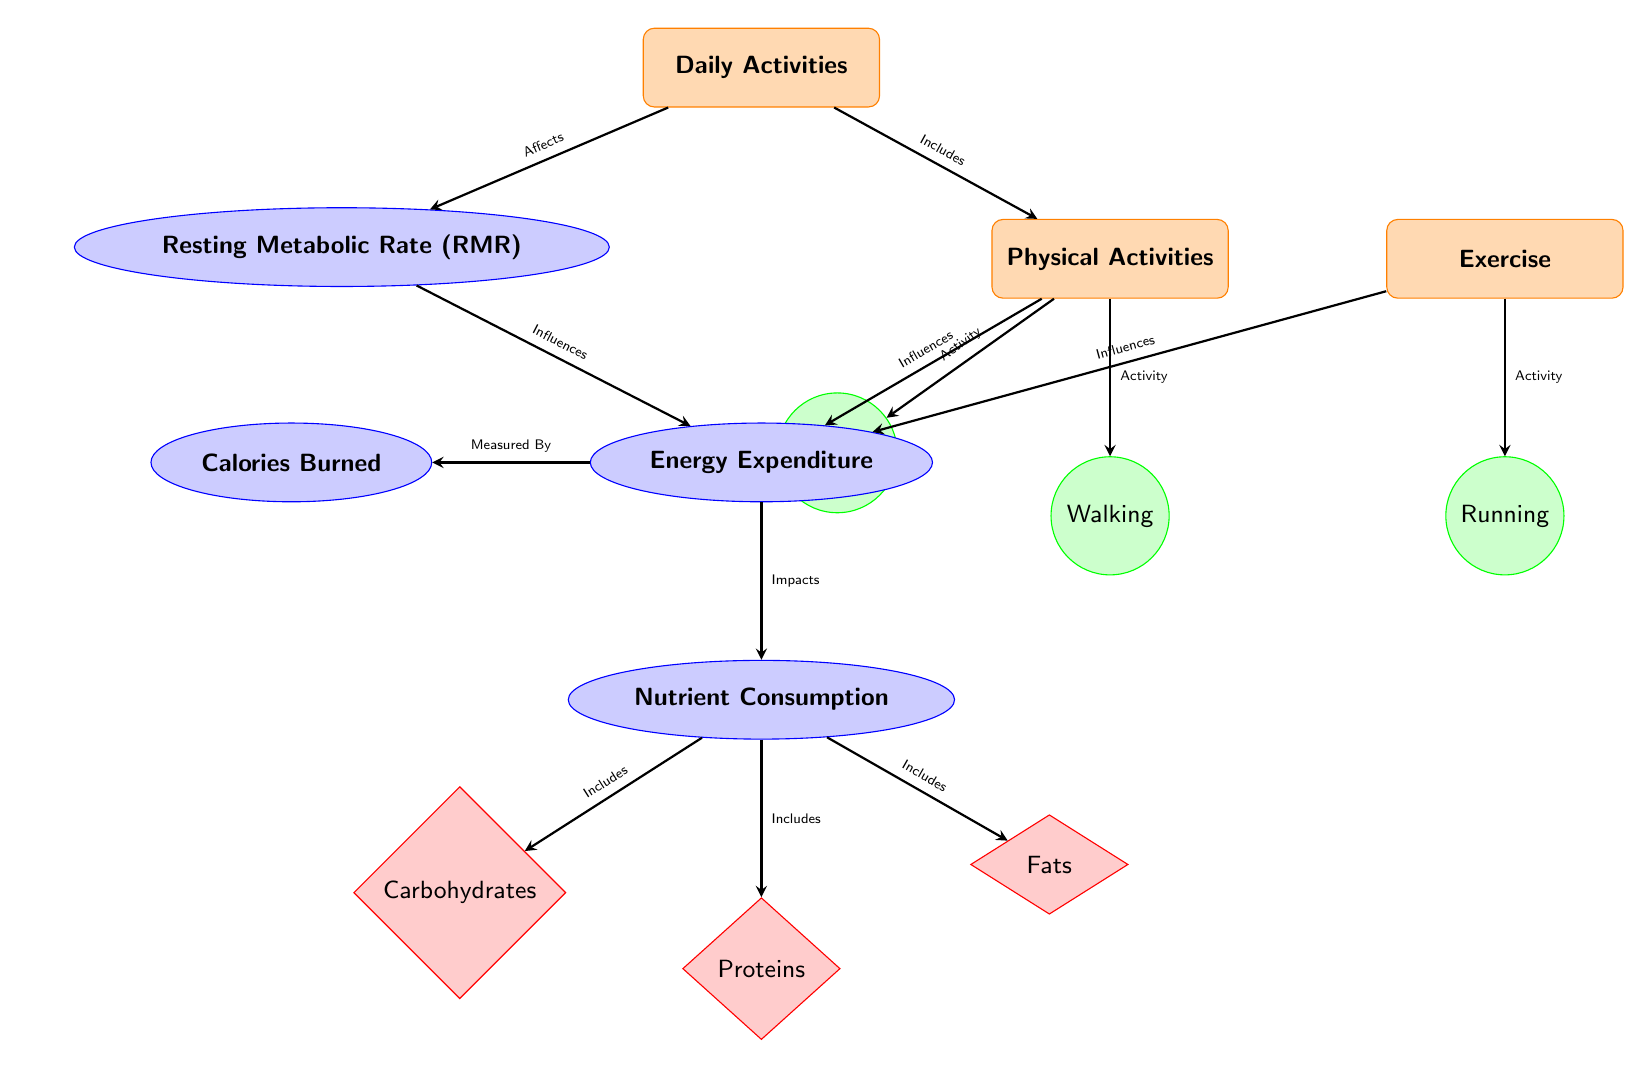What's the relationship between "Daily Activities" and "Resting Metabolic Rate (RMR)"? The arrow pointing from "Daily Activities" to "Resting Metabolic Rate (RMR)" indicates that daily activities affect the resting metabolic rate.
Answer: Affects How many types of physical activities are represented in the diagram? The diagram shows two types of physical activities: "Standing" and "Walking," as indicated by the nodes under "Physical Activities."
Answer: 2 What node comes after "Energy Expenditure"? The diagram shows that "Nutrient Consumption" follows "Energy Expenditure," as indicated by the arrow pointing downward from "Energy Expenditure."
Answer: Nutrient Consumption Which nutrient is included under "Nutrient Consumption" but does not include carbohydrates? The diagram lists "Proteins" and "Fats" under "Nutrient Consumption," meaning both are nutrients that do not include carbohydrates.
Answer: Fats What influences "Energy Expenditure"? "Resting Metabolic Rate" and "Physical Activities" both influence "Energy Expenditure," according to the arrows leading into "Energy Expenditure."
Answer: Resting Metabolic Rate, Physical Activities How is "Calories Burned" related to "Energy Expenditure"? The arrow from "Energy Expenditure" to "Calories Burned" indicates that calories burned is a measurement or result of energy expenditure.
Answer: Measured By What is the implication of daily activities on nutrient consumption in the diagram? The diagram shows that "Energy Expenditure," influenced by daily activities, impacts "Nutrient Consumption," indicating an indirect relationship through energy expenditure.
Answer: Impacts Which shape indicates "Exercise" in the diagram? The "Exercise" node is represented by a rectangle due to its category classification under "Physical Activities."
Answer: Rectangle 